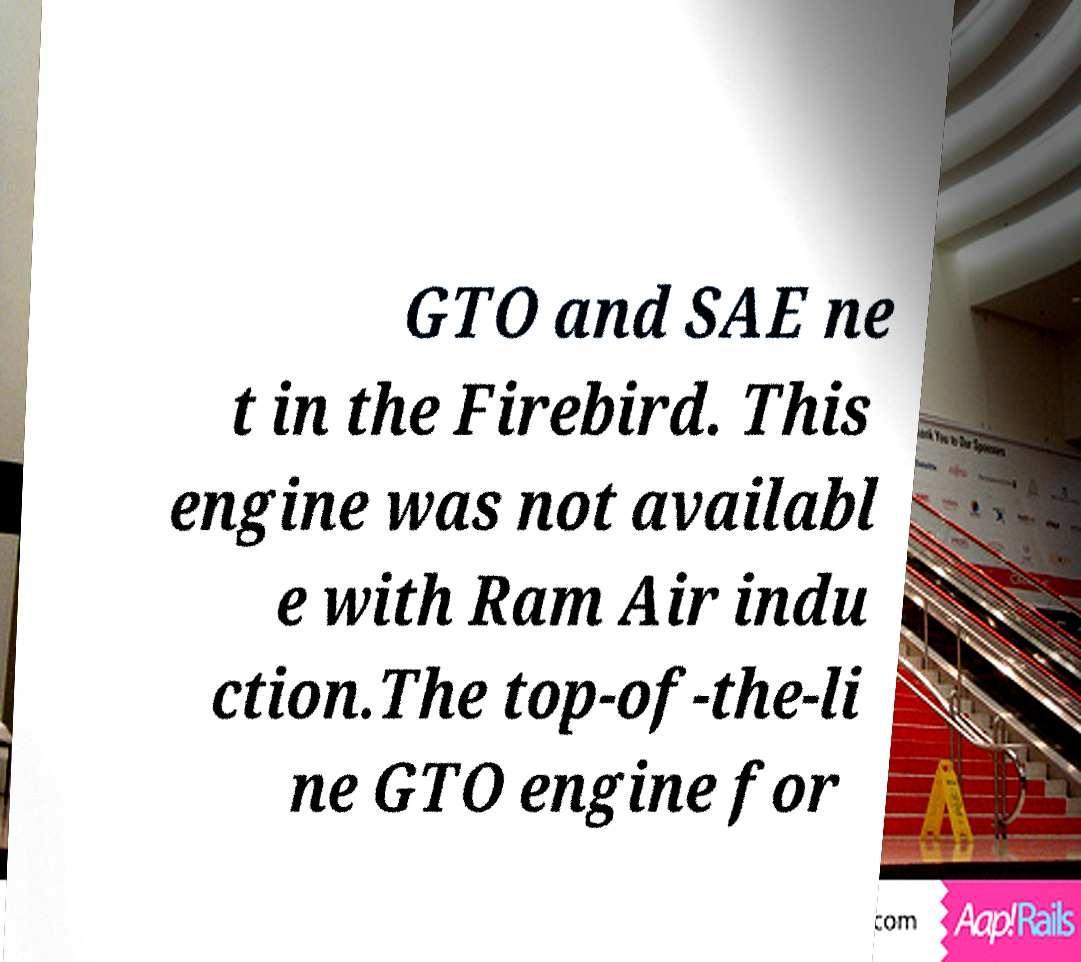Can you read and provide the text displayed in the image?This photo seems to have some interesting text. Can you extract and type it out for me? GTO and SAE ne t in the Firebird. This engine was not availabl e with Ram Air indu ction.The top-of-the-li ne GTO engine for 